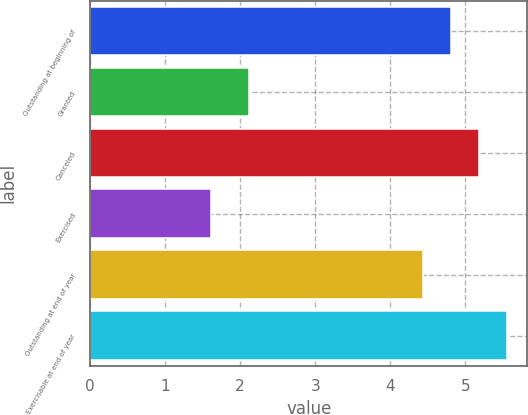Convert chart to OTSL. <chart><loc_0><loc_0><loc_500><loc_500><bar_chart><fcel>Outstanding at beginning of<fcel>Granted<fcel>Canceled<fcel>Exercised<fcel>Outstanding at end of year<fcel>Exercisable at end of year<nl><fcel>4.81<fcel>2.12<fcel>5.18<fcel>1.61<fcel>4.44<fcel>5.55<nl></chart> 